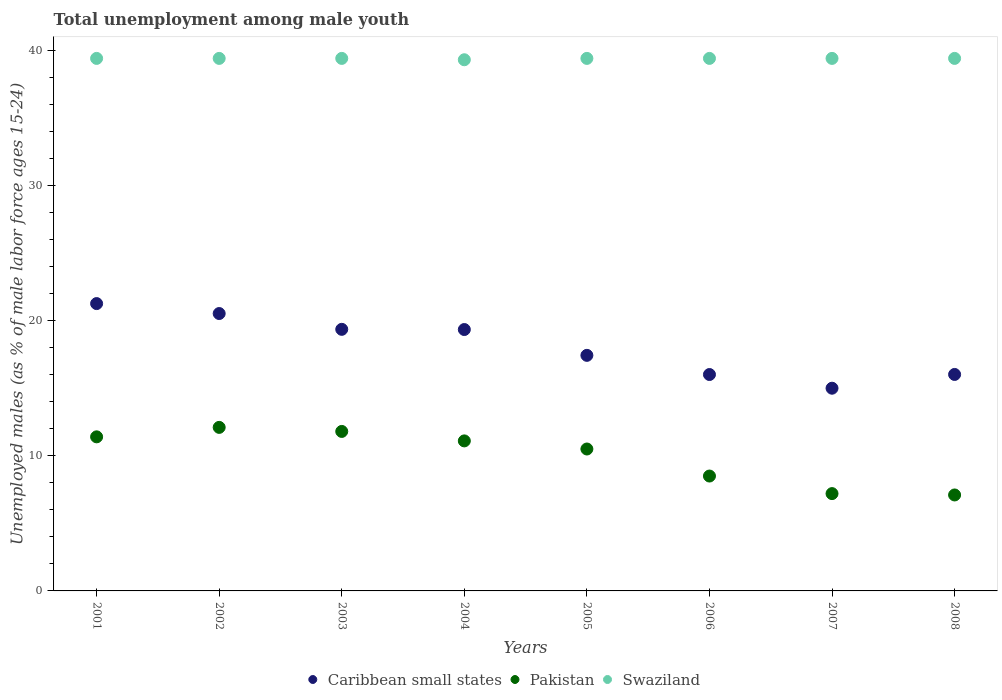Is the number of dotlines equal to the number of legend labels?
Your response must be concise. Yes. What is the percentage of unemployed males in in Pakistan in 2007?
Your answer should be very brief. 7.2. Across all years, what is the maximum percentage of unemployed males in in Swaziland?
Your answer should be compact. 39.4. Across all years, what is the minimum percentage of unemployed males in in Swaziland?
Your answer should be compact. 39.3. In which year was the percentage of unemployed males in in Swaziland minimum?
Your response must be concise. 2004. What is the total percentage of unemployed males in in Swaziland in the graph?
Keep it short and to the point. 315.1. What is the difference between the percentage of unemployed males in in Swaziland in 2004 and that in 2006?
Provide a succinct answer. -0.1. What is the difference between the percentage of unemployed males in in Pakistan in 2003 and the percentage of unemployed males in in Caribbean small states in 2001?
Offer a very short reply. -9.46. What is the average percentage of unemployed males in in Swaziland per year?
Your answer should be compact. 39.39. In the year 2002, what is the difference between the percentage of unemployed males in in Pakistan and percentage of unemployed males in in Swaziland?
Ensure brevity in your answer.  -27.3. In how many years, is the percentage of unemployed males in in Caribbean small states greater than 4 %?
Keep it short and to the point. 8. What is the ratio of the percentage of unemployed males in in Caribbean small states in 2002 to that in 2008?
Your answer should be very brief. 1.28. What is the difference between the highest and the second highest percentage of unemployed males in in Pakistan?
Provide a short and direct response. 0.3. What is the difference between the highest and the lowest percentage of unemployed males in in Pakistan?
Your answer should be very brief. 5. In how many years, is the percentage of unemployed males in in Pakistan greater than the average percentage of unemployed males in in Pakistan taken over all years?
Offer a very short reply. 5. Does the percentage of unemployed males in in Swaziland monotonically increase over the years?
Your response must be concise. No. Is the percentage of unemployed males in in Caribbean small states strictly greater than the percentage of unemployed males in in Swaziland over the years?
Your answer should be very brief. No. Is the percentage of unemployed males in in Pakistan strictly less than the percentage of unemployed males in in Caribbean small states over the years?
Give a very brief answer. Yes. How many dotlines are there?
Make the answer very short. 3. How many years are there in the graph?
Your response must be concise. 8. Does the graph contain any zero values?
Ensure brevity in your answer.  No. Does the graph contain grids?
Make the answer very short. No. How many legend labels are there?
Provide a succinct answer. 3. How are the legend labels stacked?
Offer a terse response. Horizontal. What is the title of the graph?
Ensure brevity in your answer.  Total unemployment among male youth. Does "Ireland" appear as one of the legend labels in the graph?
Offer a terse response. No. What is the label or title of the X-axis?
Offer a terse response. Years. What is the label or title of the Y-axis?
Keep it short and to the point. Unemployed males (as % of male labor force ages 15-24). What is the Unemployed males (as % of male labor force ages 15-24) in Caribbean small states in 2001?
Keep it short and to the point. 21.26. What is the Unemployed males (as % of male labor force ages 15-24) of Pakistan in 2001?
Your answer should be compact. 11.4. What is the Unemployed males (as % of male labor force ages 15-24) of Swaziland in 2001?
Provide a succinct answer. 39.4. What is the Unemployed males (as % of male labor force ages 15-24) in Caribbean small states in 2002?
Your answer should be very brief. 20.52. What is the Unemployed males (as % of male labor force ages 15-24) of Pakistan in 2002?
Provide a short and direct response. 12.1. What is the Unemployed males (as % of male labor force ages 15-24) in Swaziland in 2002?
Your answer should be compact. 39.4. What is the Unemployed males (as % of male labor force ages 15-24) of Caribbean small states in 2003?
Provide a short and direct response. 19.35. What is the Unemployed males (as % of male labor force ages 15-24) in Pakistan in 2003?
Make the answer very short. 11.8. What is the Unemployed males (as % of male labor force ages 15-24) in Swaziland in 2003?
Provide a succinct answer. 39.4. What is the Unemployed males (as % of male labor force ages 15-24) of Caribbean small states in 2004?
Your answer should be very brief. 19.34. What is the Unemployed males (as % of male labor force ages 15-24) in Pakistan in 2004?
Provide a short and direct response. 11.1. What is the Unemployed males (as % of male labor force ages 15-24) in Swaziland in 2004?
Your response must be concise. 39.3. What is the Unemployed males (as % of male labor force ages 15-24) of Caribbean small states in 2005?
Your response must be concise. 17.43. What is the Unemployed males (as % of male labor force ages 15-24) of Pakistan in 2005?
Keep it short and to the point. 10.5. What is the Unemployed males (as % of male labor force ages 15-24) in Swaziland in 2005?
Provide a short and direct response. 39.4. What is the Unemployed males (as % of male labor force ages 15-24) of Caribbean small states in 2006?
Your answer should be compact. 16.01. What is the Unemployed males (as % of male labor force ages 15-24) of Swaziland in 2006?
Your answer should be very brief. 39.4. What is the Unemployed males (as % of male labor force ages 15-24) in Caribbean small states in 2007?
Your response must be concise. 15. What is the Unemployed males (as % of male labor force ages 15-24) in Pakistan in 2007?
Keep it short and to the point. 7.2. What is the Unemployed males (as % of male labor force ages 15-24) in Swaziland in 2007?
Offer a terse response. 39.4. What is the Unemployed males (as % of male labor force ages 15-24) in Caribbean small states in 2008?
Offer a terse response. 16.02. What is the Unemployed males (as % of male labor force ages 15-24) of Pakistan in 2008?
Provide a succinct answer. 7.1. What is the Unemployed males (as % of male labor force ages 15-24) in Swaziland in 2008?
Provide a short and direct response. 39.4. Across all years, what is the maximum Unemployed males (as % of male labor force ages 15-24) of Caribbean small states?
Give a very brief answer. 21.26. Across all years, what is the maximum Unemployed males (as % of male labor force ages 15-24) in Pakistan?
Keep it short and to the point. 12.1. Across all years, what is the maximum Unemployed males (as % of male labor force ages 15-24) in Swaziland?
Your answer should be compact. 39.4. Across all years, what is the minimum Unemployed males (as % of male labor force ages 15-24) of Caribbean small states?
Make the answer very short. 15. Across all years, what is the minimum Unemployed males (as % of male labor force ages 15-24) in Pakistan?
Offer a very short reply. 7.1. Across all years, what is the minimum Unemployed males (as % of male labor force ages 15-24) of Swaziland?
Offer a very short reply. 39.3. What is the total Unemployed males (as % of male labor force ages 15-24) in Caribbean small states in the graph?
Your answer should be very brief. 144.93. What is the total Unemployed males (as % of male labor force ages 15-24) in Pakistan in the graph?
Provide a short and direct response. 79.7. What is the total Unemployed males (as % of male labor force ages 15-24) of Swaziland in the graph?
Give a very brief answer. 315.1. What is the difference between the Unemployed males (as % of male labor force ages 15-24) in Caribbean small states in 2001 and that in 2002?
Keep it short and to the point. 0.74. What is the difference between the Unemployed males (as % of male labor force ages 15-24) of Pakistan in 2001 and that in 2002?
Ensure brevity in your answer.  -0.7. What is the difference between the Unemployed males (as % of male labor force ages 15-24) of Caribbean small states in 2001 and that in 2003?
Your answer should be compact. 1.91. What is the difference between the Unemployed males (as % of male labor force ages 15-24) in Pakistan in 2001 and that in 2003?
Ensure brevity in your answer.  -0.4. What is the difference between the Unemployed males (as % of male labor force ages 15-24) in Caribbean small states in 2001 and that in 2004?
Provide a succinct answer. 1.92. What is the difference between the Unemployed males (as % of male labor force ages 15-24) in Caribbean small states in 2001 and that in 2005?
Your response must be concise. 3.83. What is the difference between the Unemployed males (as % of male labor force ages 15-24) in Caribbean small states in 2001 and that in 2006?
Provide a succinct answer. 5.25. What is the difference between the Unemployed males (as % of male labor force ages 15-24) in Swaziland in 2001 and that in 2006?
Provide a succinct answer. 0. What is the difference between the Unemployed males (as % of male labor force ages 15-24) of Caribbean small states in 2001 and that in 2007?
Offer a terse response. 6.26. What is the difference between the Unemployed males (as % of male labor force ages 15-24) in Caribbean small states in 2001 and that in 2008?
Offer a terse response. 5.24. What is the difference between the Unemployed males (as % of male labor force ages 15-24) of Caribbean small states in 2002 and that in 2003?
Provide a succinct answer. 1.17. What is the difference between the Unemployed males (as % of male labor force ages 15-24) of Caribbean small states in 2002 and that in 2004?
Your response must be concise. 1.18. What is the difference between the Unemployed males (as % of male labor force ages 15-24) of Pakistan in 2002 and that in 2004?
Your answer should be compact. 1. What is the difference between the Unemployed males (as % of male labor force ages 15-24) in Caribbean small states in 2002 and that in 2005?
Make the answer very short. 3.09. What is the difference between the Unemployed males (as % of male labor force ages 15-24) of Swaziland in 2002 and that in 2005?
Your answer should be compact. 0. What is the difference between the Unemployed males (as % of male labor force ages 15-24) in Caribbean small states in 2002 and that in 2006?
Give a very brief answer. 4.51. What is the difference between the Unemployed males (as % of male labor force ages 15-24) in Caribbean small states in 2002 and that in 2007?
Offer a very short reply. 5.53. What is the difference between the Unemployed males (as % of male labor force ages 15-24) in Caribbean small states in 2002 and that in 2008?
Your answer should be very brief. 4.51. What is the difference between the Unemployed males (as % of male labor force ages 15-24) of Caribbean small states in 2003 and that in 2004?
Your answer should be very brief. 0.01. What is the difference between the Unemployed males (as % of male labor force ages 15-24) in Pakistan in 2003 and that in 2004?
Offer a terse response. 0.7. What is the difference between the Unemployed males (as % of male labor force ages 15-24) in Swaziland in 2003 and that in 2004?
Your answer should be very brief. 0.1. What is the difference between the Unemployed males (as % of male labor force ages 15-24) of Caribbean small states in 2003 and that in 2005?
Provide a succinct answer. 1.92. What is the difference between the Unemployed males (as % of male labor force ages 15-24) in Pakistan in 2003 and that in 2005?
Your response must be concise. 1.3. What is the difference between the Unemployed males (as % of male labor force ages 15-24) in Swaziland in 2003 and that in 2005?
Offer a terse response. 0. What is the difference between the Unemployed males (as % of male labor force ages 15-24) of Caribbean small states in 2003 and that in 2006?
Your answer should be very brief. 3.34. What is the difference between the Unemployed males (as % of male labor force ages 15-24) in Caribbean small states in 2003 and that in 2007?
Offer a terse response. 4.36. What is the difference between the Unemployed males (as % of male labor force ages 15-24) in Caribbean small states in 2003 and that in 2008?
Your answer should be very brief. 3.34. What is the difference between the Unemployed males (as % of male labor force ages 15-24) in Pakistan in 2003 and that in 2008?
Your answer should be very brief. 4.7. What is the difference between the Unemployed males (as % of male labor force ages 15-24) of Swaziland in 2003 and that in 2008?
Ensure brevity in your answer.  0. What is the difference between the Unemployed males (as % of male labor force ages 15-24) of Caribbean small states in 2004 and that in 2005?
Your answer should be very brief. 1.91. What is the difference between the Unemployed males (as % of male labor force ages 15-24) in Pakistan in 2004 and that in 2005?
Provide a short and direct response. 0.6. What is the difference between the Unemployed males (as % of male labor force ages 15-24) of Swaziland in 2004 and that in 2005?
Offer a terse response. -0.1. What is the difference between the Unemployed males (as % of male labor force ages 15-24) in Caribbean small states in 2004 and that in 2006?
Provide a short and direct response. 3.33. What is the difference between the Unemployed males (as % of male labor force ages 15-24) in Caribbean small states in 2004 and that in 2007?
Your answer should be compact. 4.34. What is the difference between the Unemployed males (as % of male labor force ages 15-24) in Swaziland in 2004 and that in 2007?
Keep it short and to the point. -0.1. What is the difference between the Unemployed males (as % of male labor force ages 15-24) in Caribbean small states in 2004 and that in 2008?
Keep it short and to the point. 3.32. What is the difference between the Unemployed males (as % of male labor force ages 15-24) in Pakistan in 2004 and that in 2008?
Keep it short and to the point. 4. What is the difference between the Unemployed males (as % of male labor force ages 15-24) in Caribbean small states in 2005 and that in 2006?
Give a very brief answer. 1.42. What is the difference between the Unemployed males (as % of male labor force ages 15-24) in Caribbean small states in 2005 and that in 2007?
Your answer should be very brief. 2.43. What is the difference between the Unemployed males (as % of male labor force ages 15-24) in Pakistan in 2005 and that in 2007?
Make the answer very short. 3.3. What is the difference between the Unemployed males (as % of male labor force ages 15-24) in Swaziland in 2005 and that in 2007?
Keep it short and to the point. 0. What is the difference between the Unemployed males (as % of male labor force ages 15-24) in Caribbean small states in 2005 and that in 2008?
Your answer should be very brief. 1.41. What is the difference between the Unemployed males (as % of male labor force ages 15-24) of Pakistan in 2005 and that in 2008?
Your response must be concise. 3.4. What is the difference between the Unemployed males (as % of male labor force ages 15-24) of Caribbean small states in 2006 and that in 2007?
Ensure brevity in your answer.  1.01. What is the difference between the Unemployed males (as % of male labor force ages 15-24) in Pakistan in 2006 and that in 2007?
Your response must be concise. 1.3. What is the difference between the Unemployed males (as % of male labor force ages 15-24) in Caribbean small states in 2006 and that in 2008?
Provide a short and direct response. -0.01. What is the difference between the Unemployed males (as % of male labor force ages 15-24) of Caribbean small states in 2007 and that in 2008?
Provide a short and direct response. -1.02. What is the difference between the Unemployed males (as % of male labor force ages 15-24) in Swaziland in 2007 and that in 2008?
Make the answer very short. 0. What is the difference between the Unemployed males (as % of male labor force ages 15-24) of Caribbean small states in 2001 and the Unemployed males (as % of male labor force ages 15-24) of Pakistan in 2002?
Your answer should be compact. 9.16. What is the difference between the Unemployed males (as % of male labor force ages 15-24) in Caribbean small states in 2001 and the Unemployed males (as % of male labor force ages 15-24) in Swaziland in 2002?
Your answer should be compact. -18.14. What is the difference between the Unemployed males (as % of male labor force ages 15-24) of Pakistan in 2001 and the Unemployed males (as % of male labor force ages 15-24) of Swaziland in 2002?
Your response must be concise. -28. What is the difference between the Unemployed males (as % of male labor force ages 15-24) in Caribbean small states in 2001 and the Unemployed males (as % of male labor force ages 15-24) in Pakistan in 2003?
Your answer should be compact. 9.46. What is the difference between the Unemployed males (as % of male labor force ages 15-24) in Caribbean small states in 2001 and the Unemployed males (as % of male labor force ages 15-24) in Swaziland in 2003?
Your answer should be compact. -18.14. What is the difference between the Unemployed males (as % of male labor force ages 15-24) of Caribbean small states in 2001 and the Unemployed males (as % of male labor force ages 15-24) of Pakistan in 2004?
Offer a terse response. 10.16. What is the difference between the Unemployed males (as % of male labor force ages 15-24) of Caribbean small states in 2001 and the Unemployed males (as % of male labor force ages 15-24) of Swaziland in 2004?
Your answer should be very brief. -18.04. What is the difference between the Unemployed males (as % of male labor force ages 15-24) in Pakistan in 2001 and the Unemployed males (as % of male labor force ages 15-24) in Swaziland in 2004?
Ensure brevity in your answer.  -27.9. What is the difference between the Unemployed males (as % of male labor force ages 15-24) of Caribbean small states in 2001 and the Unemployed males (as % of male labor force ages 15-24) of Pakistan in 2005?
Provide a short and direct response. 10.76. What is the difference between the Unemployed males (as % of male labor force ages 15-24) of Caribbean small states in 2001 and the Unemployed males (as % of male labor force ages 15-24) of Swaziland in 2005?
Keep it short and to the point. -18.14. What is the difference between the Unemployed males (as % of male labor force ages 15-24) in Pakistan in 2001 and the Unemployed males (as % of male labor force ages 15-24) in Swaziland in 2005?
Provide a short and direct response. -28. What is the difference between the Unemployed males (as % of male labor force ages 15-24) in Caribbean small states in 2001 and the Unemployed males (as % of male labor force ages 15-24) in Pakistan in 2006?
Ensure brevity in your answer.  12.76. What is the difference between the Unemployed males (as % of male labor force ages 15-24) of Caribbean small states in 2001 and the Unemployed males (as % of male labor force ages 15-24) of Swaziland in 2006?
Ensure brevity in your answer.  -18.14. What is the difference between the Unemployed males (as % of male labor force ages 15-24) of Pakistan in 2001 and the Unemployed males (as % of male labor force ages 15-24) of Swaziland in 2006?
Make the answer very short. -28. What is the difference between the Unemployed males (as % of male labor force ages 15-24) in Caribbean small states in 2001 and the Unemployed males (as % of male labor force ages 15-24) in Pakistan in 2007?
Your answer should be very brief. 14.06. What is the difference between the Unemployed males (as % of male labor force ages 15-24) of Caribbean small states in 2001 and the Unemployed males (as % of male labor force ages 15-24) of Swaziland in 2007?
Your answer should be compact. -18.14. What is the difference between the Unemployed males (as % of male labor force ages 15-24) in Pakistan in 2001 and the Unemployed males (as % of male labor force ages 15-24) in Swaziland in 2007?
Offer a very short reply. -28. What is the difference between the Unemployed males (as % of male labor force ages 15-24) in Caribbean small states in 2001 and the Unemployed males (as % of male labor force ages 15-24) in Pakistan in 2008?
Offer a terse response. 14.16. What is the difference between the Unemployed males (as % of male labor force ages 15-24) in Caribbean small states in 2001 and the Unemployed males (as % of male labor force ages 15-24) in Swaziland in 2008?
Give a very brief answer. -18.14. What is the difference between the Unemployed males (as % of male labor force ages 15-24) of Pakistan in 2001 and the Unemployed males (as % of male labor force ages 15-24) of Swaziland in 2008?
Ensure brevity in your answer.  -28. What is the difference between the Unemployed males (as % of male labor force ages 15-24) of Caribbean small states in 2002 and the Unemployed males (as % of male labor force ages 15-24) of Pakistan in 2003?
Offer a terse response. 8.72. What is the difference between the Unemployed males (as % of male labor force ages 15-24) in Caribbean small states in 2002 and the Unemployed males (as % of male labor force ages 15-24) in Swaziland in 2003?
Your answer should be very brief. -18.88. What is the difference between the Unemployed males (as % of male labor force ages 15-24) of Pakistan in 2002 and the Unemployed males (as % of male labor force ages 15-24) of Swaziland in 2003?
Make the answer very short. -27.3. What is the difference between the Unemployed males (as % of male labor force ages 15-24) in Caribbean small states in 2002 and the Unemployed males (as % of male labor force ages 15-24) in Pakistan in 2004?
Give a very brief answer. 9.42. What is the difference between the Unemployed males (as % of male labor force ages 15-24) in Caribbean small states in 2002 and the Unemployed males (as % of male labor force ages 15-24) in Swaziland in 2004?
Provide a succinct answer. -18.78. What is the difference between the Unemployed males (as % of male labor force ages 15-24) of Pakistan in 2002 and the Unemployed males (as % of male labor force ages 15-24) of Swaziland in 2004?
Provide a short and direct response. -27.2. What is the difference between the Unemployed males (as % of male labor force ages 15-24) in Caribbean small states in 2002 and the Unemployed males (as % of male labor force ages 15-24) in Pakistan in 2005?
Your answer should be very brief. 10.02. What is the difference between the Unemployed males (as % of male labor force ages 15-24) of Caribbean small states in 2002 and the Unemployed males (as % of male labor force ages 15-24) of Swaziland in 2005?
Keep it short and to the point. -18.88. What is the difference between the Unemployed males (as % of male labor force ages 15-24) of Pakistan in 2002 and the Unemployed males (as % of male labor force ages 15-24) of Swaziland in 2005?
Provide a short and direct response. -27.3. What is the difference between the Unemployed males (as % of male labor force ages 15-24) in Caribbean small states in 2002 and the Unemployed males (as % of male labor force ages 15-24) in Pakistan in 2006?
Offer a terse response. 12.02. What is the difference between the Unemployed males (as % of male labor force ages 15-24) in Caribbean small states in 2002 and the Unemployed males (as % of male labor force ages 15-24) in Swaziland in 2006?
Your response must be concise. -18.88. What is the difference between the Unemployed males (as % of male labor force ages 15-24) in Pakistan in 2002 and the Unemployed males (as % of male labor force ages 15-24) in Swaziland in 2006?
Your answer should be compact. -27.3. What is the difference between the Unemployed males (as % of male labor force ages 15-24) in Caribbean small states in 2002 and the Unemployed males (as % of male labor force ages 15-24) in Pakistan in 2007?
Your answer should be compact. 13.32. What is the difference between the Unemployed males (as % of male labor force ages 15-24) of Caribbean small states in 2002 and the Unemployed males (as % of male labor force ages 15-24) of Swaziland in 2007?
Keep it short and to the point. -18.88. What is the difference between the Unemployed males (as % of male labor force ages 15-24) of Pakistan in 2002 and the Unemployed males (as % of male labor force ages 15-24) of Swaziland in 2007?
Your answer should be compact. -27.3. What is the difference between the Unemployed males (as % of male labor force ages 15-24) in Caribbean small states in 2002 and the Unemployed males (as % of male labor force ages 15-24) in Pakistan in 2008?
Ensure brevity in your answer.  13.42. What is the difference between the Unemployed males (as % of male labor force ages 15-24) of Caribbean small states in 2002 and the Unemployed males (as % of male labor force ages 15-24) of Swaziland in 2008?
Your response must be concise. -18.88. What is the difference between the Unemployed males (as % of male labor force ages 15-24) of Pakistan in 2002 and the Unemployed males (as % of male labor force ages 15-24) of Swaziland in 2008?
Ensure brevity in your answer.  -27.3. What is the difference between the Unemployed males (as % of male labor force ages 15-24) in Caribbean small states in 2003 and the Unemployed males (as % of male labor force ages 15-24) in Pakistan in 2004?
Make the answer very short. 8.25. What is the difference between the Unemployed males (as % of male labor force ages 15-24) in Caribbean small states in 2003 and the Unemployed males (as % of male labor force ages 15-24) in Swaziland in 2004?
Make the answer very short. -19.95. What is the difference between the Unemployed males (as % of male labor force ages 15-24) of Pakistan in 2003 and the Unemployed males (as % of male labor force ages 15-24) of Swaziland in 2004?
Ensure brevity in your answer.  -27.5. What is the difference between the Unemployed males (as % of male labor force ages 15-24) of Caribbean small states in 2003 and the Unemployed males (as % of male labor force ages 15-24) of Pakistan in 2005?
Keep it short and to the point. 8.85. What is the difference between the Unemployed males (as % of male labor force ages 15-24) in Caribbean small states in 2003 and the Unemployed males (as % of male labor force ages 15-24) in Swaziland in 2005?
Your response must be concise. -20.05. What is the difference between the Unemployed males (as % of male labor force ages 15-24) of Pakistan in 2003 and the Unemployed males (as % of male labor force ages 15-24) of Swaziland in 2005?
Keep it short and to the point. -27.6. What is the difference between the Unemployed males (as % of male labor force ages 15-24) in Caribbean small states in 2003 and the Unemployed males (as % of male labor force ages 15-24) in Pakistan in 2006?
Keep it short and to the point. 10.85. What is the difference between the Unemployed males (as % of male labor force ages 15-24) in Caribbean small states in 2003 and the Unemployed males (as % of male labor force ages 15-24) in Swaziland in 2006?
Your answer should be very brief. -20.05. What is the difference between the Unemployed males (as % of male labor force ages 15-24) in Pakistan in 2003 and the Unemployed males (as % of male labor force ages 15-24) in Swaziland in 2006?
Provide a succinct answer. -27.6. What is the difference between the Unemployed males (as % of male labor force ages 15-24) in Caribbean small states in 2003 and the Unemployed males (as % of male labor force ages 15-24) in Pakistan in 2007?
Give a very brief answer. 12.15. What is the difference between the Unemployed males (as % of male labor force ages 15-24) in Caribbean small states in 2003 and the Unemployed males (as % of male labor force ages 15-24) in Swaziland in 2007?
Provide a succinct answer. -20.05. What is the difference between the Unemployed males (as % of male labor force ages 15-24) of Pakistan in 2003 and the Unemployed males (as % of male labor force ages 15-24) of Swaziland in 2007?
Provide a short and direct response. -27.6. What is the difference between the Unemployed males (as % of male labor force ages 15-24) in Caribbean small states in 2003 and the Unemployed males (as % of male labor force ages 15-24) in Pakistan in 2008?
Make the answer very short. 12.25. What is the difference between the Unemployed males (as % of male labor force ages 15-24) of Caribbean small states in 2003 and the Unemployed males (as % of male labor force ages 15-24) of Swaziland in 2008?
Provide a short and direct response. -20.05. What is the difference between the Unemployed males (as % of male labor force ages 15-24) in Pakistan in 2003 and the Unemployed males (as % of male labor force ages 15-24) in Swaziland in 2008?
Make the answer very short. -27.6. What is the difference between the Unemployed males (as % of male labor force ages 15-24) in Caribbean small states in 2004 and the Unemployed males (as % of male labor force ages 15-24) in Pakistan in 2005?
Keep it short and to the point. 8.84. What is the difference between the Unemployed males (as % of male labor force ages 15-24) in Caribbean small states in 2004 and the Unemployed males (as % of male labor force ages 15-24) in Swaziland in 2005?
Ensure brevity in your answer.  -20.06. What is the difference between the Unemployed males (as % of male labor force ages 15-24) of Pakistan in 2004 and the Unemployed males (as % of male labor force ages 15-24) of Swaziland in 2005?
Provide a succinct answer. -28.3. What is the difference between the Unemployed males (as % of male labor force ages 15-24) in Caribbean small states in 2004 and the Unemployed males (as % of male labor force ages 15-24) in Pakistan in 2006?
Offer a terse response. 10.84. What is the difference between the Unemployed males (as % of male labor force ages 15-24) in Caribbean small states in 2004 and the Unemployed males (as % of male labor force ages 15-24) in Swaziland in 2006?
Give a very brief answer. -20.06. What is the difference between the Unemployed males (as % of male labor force ages 15-24) in Pakistan in 2004 and the Unemployed males (as % of male labor force ages 15-24) in Swaziland in 2006?
Offer a very short reply. -28.3. What is the difference between the Unemployed males (as % of male labor force ages 15-24) of Caribbean small states in 2004 and the Unemployed males (as % of male labor force ages 15-24) of Pakistan in 2007?
Keep it short and to the point. 12.14. What is the difference between the Unemployed males (as % of male labor force ages 15-24) in Caribbean small states in 2004 and the Unemployed males (as % of male labor force ages 15-24) in Swaziland in 2007?
Make the answer very short. -20.06. What is the difference between the Unemployed males (as % of male labor force ages 15-24) of Pakistan in 2004 and the Unemployed males (as % of male labor force ages 15-24) of Swaziland in 2007?
Keep it short and to the point. -28.3. What is the difference between the Unemployed males (as % of male labor force ages 15-24) in Caribbean small states in 2004 and the Unemployed males (as % of male labor force ages 15-24) in Pakistan in 2008?
Ensure brevity in your answer.  12.24. What is the difference between the Unemployed males (as % of male labor force ages 15-24) in Caribbean small states in 2004 and the Unemployed males (as % of male labor force ages 15-24) in Swaziland in 2008?
Offer a very short reply. -20.06. What is the difference between the Unemployed males (as % of male labor force ages 15-24) in Pakistan in 2004 and the Unemployed males (as % of male labor force ages 15-24) in Swaziland in 2008?
Provide a short and direct response. -28.3. What is the difference between the Unemployed males (as % of male labor force ages 15-24) of Caribbean small states in 2005 and the Unemployed males (as % of male labor force ages 15-24) of Pakistan in 2006?
Keep it short and to the point. 8.93. What is the difference between the Unemployed males (as % of male labor force ages 15-24) in Caribbean small states in 2005 and the Unemployed males (as % of male labor force ages 15-24) in Swaziland in 2006?
Keep it short and to the point. -21.97. What is the difference between the Unemployed males (as % of male labor force ages 15-24) in Pakistan in 2005 and the Unemployed males (as % of male labor force ages 15-24) in Swaziland in 2006?
Provide a succinct answer. -28.9. What is the difference between the Unemployed males (as % of male labor force ages 15-24) in Caribbean small states in 2005 and the Unemployed males (as % of male labor force ages 15-24) in Pakistan in 2007?
Your answer should be compact. 10.23. What is the difference between the Unemployed males (as % of male labor force ages 15-24) in Caribbean small states in 2005 and the Unemployed males (as % of male labor force ages 15-24) in Swaziland in 2007?
Ensure brevity in your answer.  -21.97. What is the difference between the Unemployed males (as % of male labor force ages 15-24) in Pakistan in 2005 and the Unemployed males (as % of male labor force ages 15-24) in Swaziland in 2007?
Keep it short and to the point. -28.9. What is the difference between the Unemployed males (as % of male labor force ages 15-24) of Caribbean small states in 2005 and the Unemployed males (as % of male labor force ages 15-24) of Pakistan in 2008?
Give a very brief answer. 10.33. What is the difference between the Unemployed males (as % of male labor force ages 15-24) of Caribbean small states in 2005 and the Unemployed males (as % of male labor force ages 15-24) of Swaziland in 2008?
Keep it short and to the point. -21.97. What is the difference between the Unemployed males (as % of male labor force ages 15-24) of Pakistan in 2005 and the Unemployed males (as % of male labor force ages 15-24) of Swaziland in 2008?
Your answer should be very brief. -28.9. What is the difference between the Unemployed males (as % of male labor force ages 15-24) in Caribbean small states in 2006 and the Unemployed males (as % of male labor force ages 15-24) in Pakistan in 2007?
Provide a short and direct response. 8.81. What is the difference between the Unemployed males (as % of male labor force ages 15-24) of Caribbean small states in 2006 and the Unemployed males (as % of male labor force ages 15-24) of Swaziland in 2007?
Make the answer very short. -23.39. What is the difference between the Unemployed males (as % of male labor force ages 15-24) in Pakistan in 2006 and the Unemployed males (as % of male labor force ages 15-24) in Swaziland in 2007?
Provide a short and direct response. -30.9. What is the difference between the Unemployed males (as % of male labor force ages 15-24) of Caribbean small states in 2006 and the Unemployed males (as % of male labor force ages 15-24) of Pakistan in 2008?
Provide a short and direct response. 8.91. What is the difference between the Unemployed males (as % of male labor force ages 15-24) of Caribbean small states in 2006 and the Unemployed males (as % of male labor force ages 15-24) of Swaziland in 2008?
Offer a very short reply. -23.39. What is the difference between the Unemployed males (as % of male labor force ages 15-24) in Pakistan in 2006 and the Unemployed males (as % of male labor force ages 15-24) in Swaziland in 2008?
Your answer should be compact. -30.9. What is the difference between the Unemployed males (as % of male labor force ages 15-24) of Caribbean small states in 2007 and the Unemployed males (as % of male labor force ages 15-24) of Pakistan in 2008?
Give a very brief answer. 7.9. What is the difference between the Unemployed males (as % of male labor force ages 15-24) in Caribbean small states in 2007 and the Unemployed males (as % of male labor force ages 15-24) in Swaziland in 2008?
Your response must be concise. -24.4. What is the difference between the Unemployed males (as % of male labor force ages 15-24) of Pakistan in 2007 and the Unemployed males (as % of male labor force ages 15-24) of Swaziland in 2008?
Make the answer very short. -32.2. What is the average Unemployed males (as % of male labor force ages 15-24) in Caribbean small states per year?
Provide a succinct answer. 18.12. What is the average Unemployed males (as % of male labor force ages 15-24) of Pakistan per year?
Provide a short and direct response. 9.96. What is the average Unemployed males (as % of male labor force ages 15-24) in Swaziland per year?
Provide a succinct answer. 39.39. In the year 2001, what is the difference between the Unemployed males (as % of male labor force ages 15-24) in Caribbean small states and Unemployed males (as % of male labor force ages 15-24) in Pakistan?
Provide a succinct answer. 9.86. In the year 2001, what is the difference between the Unemployed males (as % of male labor force ages 15-24) in Caribbean small states and Unemployed males (as % of male labor force ages 15-24) in Swaziland?
Provide a succinct answer. -18.14. In the year 2001, what is the difference between the Unemployed males (as % of male labor force ages 15-24) in Pakistan and Unemployed males (as % of male labor force ages 15-24) in Swaziland?
Keep it short and to the point. -28. In the year 2002, what is the difference between the Unemployed males (as % of male labor force ages 15-24) of Caribbean small states and Unemployed males (as % of male labor force ages 15-24) of Pakistan?
Offer a very short reply. 8.42. In the year 2002, what is the difference between the Unemployed males (as % of male labor force ages 15-24) of Caribbean small states and Unemployed males (as % of male labor force ages 15-24) of Swaziland?
Ensure brevity in your answer.  -18.88. In the year 2002, what is the difference between the Unemployed males (as % of male labor force ages 15-24) of Pakistan and Unemployed males (as % of male labor force ages 15-24) of Swaziland?
Give a very brief answer. -27.3. In the year 2003, what is the difference between the Unemployed males (as % of male labor force ages 15-24) of Caribbean small states and Unemployed males (as % of male labor force ages 15-24) of Pakistan?
Give a very brief answer. 7.55. In the year 2003, what is the difference between the Unemployed males (as % of male labor force ages 15-24) of Caribbean small states and Unemployed males (as % of male labor force ages 15-24) of Swaziland?
Ensure brevity in your answer.  -20.05. In the year 2003, what is the difference between the Unemployed males (as % of male labor force ages 15-24) of Pakistan and Unemployed males (as % of male labor force ages 15-24) of Swaziland?
Provide a succinct answer. -27.6. In the year 2004, what is the difference between the Unemployed males (as % of male labor force ages 15-24) of Caribbean small states and Unemployed males (as % of male labor force ages 15-24) of Pakistan?
Offer a very short reply. 8.24. In the year 2004, what is the difference between the Unemployed males (as % of male labor force ages 15-24) of Caribbean small states and Unemployed males (as % of male labor force ages 15-24) of Swaziland?
Keep it short and to the point. -19.96. In the year 2004, what is the difference between the Unemployed males (as % of male labor force ages 15-24) in Pakistan and Unemployed males (as % of male labor force ages 15-24) in Swaziland?
Provide a short and direct response. -28.2. In the year 2005, what is the difference between the Unemployed males (as % of male labor force ages 15-24) in Caribbean small states and Unemployed males (as % of male labor force ages 15-24) in Pakistan?
Offer a very short reply. 6.93. In the year 2005, what is the difference between the Unemployed males (as % of male labor force ages 15-24) in Caribbean small states and Unemployed males (as % of male labor force ages 15-24) in Swaziland?
Ensure brevity in your answer.  -21.97. In the year 2005, what is the difference between the Unemployed males (as % of male labor force ages 15-24) of Pakistan and Unemployed males (as % of male labor force ages 15-24) of Swaziland?
Make the answer very short. -28.9. In the year 2006, what is the difference between the Unemployed males (as % of male labor force ages 15-24) in Caribbean small states and Unemployed males (as % of male labor force ages 15-24) in Pakistan?
Ensure brevity in your answer.  7.51. In the year 2006, what is the difference between the Unemployed males (as % of male labor force ages 15-24) of Caribbean small states and Unemployed males (as % of male labor force ages 15-24) of Swaziland?
Provide a short and direct response. -23.39. In the year 2006, what is the difference between the Unemployed males (as % of male labor force ages 15-24) in Pakistan and Unemployed males (as % of male labor force ages 15-24) in Swaziland?
Your response must be concise. -30.9. In the year 2007, what is the difference between the Unemployed males (as % of male labor force ages 15-24) in Caribbean small states and Unemployed males (as % of male labor force ages 15-24) in Pakistan?
Your answer should be compact. 7.8. In the year 2007, what is the difference between the Unemployed males (as % of male labor force ages 15-24) in Caribbean small states and Unemployed males (as % of male labor force ages 15-24) in Swaziland?
Your response must be concise. -24.4. In the year 2007, what is the difference between the Unemployed males (as % of male labor force ages 15-24) in Pakistan and Unemployed males (as % of male labor force ages 15-24) in Swaziland?
Offer a very short reply. -32.2. In the year 2008, what is the difference between the Unemployed males (as % of male labor force ages 15-24) of Caribbean small states and Unemployed males (as % of male labor force ages 15-24) of Pakistan?
Ensure brevity in your answer.  8.92. In the year 2008, what is the difference between the Unemployed males (as % of male labor force ages 15-24) of Caribbean small states and Unemployed males (as % of male labor force ages 15-24) of Swaziland?
Ensure brevity in your answer.  -23.38. In the year 2008, what is the difference between the Unemployed males (as % of male labor force ages 15-24) in Pakistan and Unemployed males (as % of male labor force ages 15-24) in Swaziland?
Offer a very short reply. -32.3. What is the ratio of the Unemployed males (as % of male labor force ages 15-24) of Caribbean small states in 2001 to that in 2002?
Your answer should be compact. 1.04. What is the ratio of the Unemployed males (as % of male labor force ages 15-24) in Pakistan in 2001 to that in 2002?
Ensure brevity in your answer.  0.94. What is the ratio of the Unemployed males (as % of male labor force ages 15-24) of Caribbean small states in 2001 to that in 2003?
Your answer should be compact. 1.1. What is the ratio of the Unemployed males (as % of male labor force ages 15-24) of Pakistan in 2001 to that in 2003?
Make the answer very short. 0.97. What is the ratio of the Unemployed males (as % of male labor force ages 15-24) in Caribbean small states in 2001 to that in 2004?
Give a very brief answer. 1.1. What is the ratio of the Unemployed males (as % of male labor force ages 15-24) in Pakistan in 2001 to that in 2004?
Offer a terse response. 1.03. What is the ratio of the Unemployed males (as % of male labor force ages 15-24) in Swaziland in 2001 to that in 2004?
Offer a terse response. 1. What is the ratio of the Unemployed males (as % of male labor force ages 15-24) of Caribbean small states in 2001 to that in 2005?
Give a very brief answer. 1.22. What is the ratio of the Unemployed males (as % of male labor force ages 15-24) in Pakistan in 2001 to that in 2005?
Make the answer very short. 1.09. What is the ratio of the Unemployed males (as % of male labor force ages 15-24) in Swaziland in 2001 to that in 2005?
Make the answer very short. 1. What is the ratio of the Unemployed males (as % of male labor force ages 15-24) in Caribbean small states in 2001 to that in 2006?
Give a very brief answer. 1.33. What is the ratio of the Unemployed males (as % of male labor force ages 15-24) in Pakistan in 2001 to that in 2006?
Your response must be concise. 1.34. What is the ratio of the Unemployed males (as % of male labor force ages 15-24) in Swaziland in 2001 to that in 2006?
Offer a terse response. 1. What is the ratio of the Unemployed males (as % of male labor force ages 15-24) in Caribbean small states in 2001 to that in 2007?
Keep it short and to the point. 1.42. What is the ratio of the Unemployed males (as % of male labor force ages 15-24) of Pakistan in 2001 to that in 2007?
Ensure brevity in your answer.  1.58. What is the ratio of the Unemployed males (as % of male labor force ages 15-24) of Swaziland in 2001 to that in 2007?
Ensure brevity in your answer.  1. What is the ratio of the Unemployed males (as % of male labor force ages 15-24) of Caribbean small states in 2001 to that in 2008?
Provide a short and direct response. 1.33. What is the ratio of the Unemployed males (as % of male labor force ages 15-24) in Pakistan in 2001 to that in 2008?
Your answer should be very brief. 1.61. What is the ratio of the Unemployed males (as % of male labor force ages 15-24) in Caribbean small states in 2002 to that in 2003?
Offer a terse response. 1.06. What is the ratio of the Unemployed males (as % of male labor force ages 15-24) of Pakistan in 2002 to that in 2003?
Provide a succinct answer. 1.03. What is the ratio of the Unemployed males (as % of male labor force ages 15-24) of Caribbean small states in 2002 to that in 2004?
Keep it short and to the point. 1.06. What is the ratio of the Unemployed males (as % of male labor force ages 15-24) in Pakistan in 2002 to that in 2004?
Give a very brief answer. 1.09. What is the ratio of the Unemployed males (as % of male labor force ages 15-24) of Swaziland in 2002 to that in 2004?
Your answer should be compact. 1. What is the ratio of the Unemployed males (as % of male labor force ages 15-24) in Caribbean small states in 2002 to that in 2005?
Offer a terse response. 1.18. What is the ratio of the Unemployed males (as % of male labor force ages 15-24) of Pakistan in 2002 to that in 2005?
Keep it short and to the point. 1.15. What is the ratio of the Unemployed males (as % of male labor force ages 15-24) in Swaziland in 2002 to that in 2005?
Give a very brief answer. 1. What is the ratio of the Unemployed males (as % of male labor force ages 15-24) in Caribbean small states in 2002 to that in 2006?
Offer a terse response. 1.28. What is the ratio of the Unemployed males (as % of male labor force ages 15-24) of Pakistan in 2002 to that in 2006?
Give a very brief answer. 1.42. What is the ratio of the Unemployed males (as % of male labor force ages 15-24) in Swaziland in 2002 to that in 2006?
Offer a very short reply. 1. What is the ratio of the Unemployed males (as % of male labor force ages 15-24) in Caribbean small states in 2002 to that in 2007?
Your answer should be very brief. 1.37. What is the ratio of the Unemployed males (as % of male labor force ages 15-24) of Pakistan in 2002 to that in 2007?
Provide a succinct answer. 1.68. What is the ratio of the Unemployed males (as % of male labor force ages 15-24) of Swaziland in 2002 to that in 2007?
Offer a very short reply. 1. What is the ratio of the Unemployed males (as % of male labor force ages 15-24) in Caribbean small states in 2002 to that in 2008?
Give a very brief answer. 1.28. What is the ratio of the Unemployed males (as % of male labor force ages 15-24) of Pakistan in 2002 to that in 2008?
Provide a succinct answer. 1.7. What is the ratio of the Unemployed males (as % of male labor force ages 15-24) in Pakistan in 2003 to that in 2004?
Ensure brevity in your answer.  1.06. What is the ratio of the Unemployed males (as % of male labor force ages 15-24) in Swaziland in 2003 to that in 2004?
Offer a very short reply. 1. What is the ratio of the Unemployed males (as % of male labor force ages 15-24) in Caribbean small states in 2003 to that in 2005?
Your answer should be very brief. 1.11. What is the ratio of the Unemployed males (as % of male labor force ages 15-24) in Pakistan in 2003 to that in 2005?
Your answer should be very brief. 1.12. What is the ratio of the Unemployed males (as % of male labor force ages 15-24) of Swaziland in 2003 to that in 2005?
Give a very brief answer. 1. What is the ratio of the Unemployed males (as % of male labor force ages 15-24) of Caribbean small states in 2003 to that in 2006?
Your answer should be very brief. 1.21. What is the ratio of the Unemployed males (as % of male labor force ages 15-24) in Pakistan in 2003 to that in 2006?
Ensure brevity in your answer.  1.39. What is the ratio of the Unemployed males (as % of male labor force ages 15-24) in Caribbean small states in 2003 to that in 2007?
Give a very brief answer. 1.29. What is the ratio of the Unemployed males (as % of male labor force ages 15-24) in Pakistan in 2003 to that in 2007?
Your response must be concise. 1.64. What is the ratio of the Unemployed males (as % of male labor force ages 15-24) in Swaziland in 2003 to that in 2007?
Provide a short and direct response. 1. What is the ratio of the Unemployed males (as % of male labor force ages 15-24) of Caribbean small states in 2003 to that in 2008?
Make the answer very short. 1.21. What is the ratio of the Unemployed males (as % of male labor force ages 15-24) of Pakistan in 2003 to that in 2008?
Your response must be concise. 1.66. What is the ratio of the Unemployed males (as % of male labor force ages 15-24) of Caribbean small states in 2004 to that in 2005?
Provide a succinct answer. 1.11. What is the ratio of the Unemployed males (as % of male labor force ages 15-24) of Pakistan in 2004 to that in 2005?
Provide a short and direct response. 1.06. What is the ratio of the Unemployed males (as % of male labor force ages 15-24) in Caribbean small states in 2004 to that in 2006?
Provide a succinct answer. 1.21. What is the ratio of the Unemployed males (as % of male labor force ages 15-24) of Pakistan in 2004 to that in 2006?
Offer a terse response. 1.31. What is the ratio of the Unemployed males (as % of male labor force ages 15-24) in Swaziland in 2004 to that in 2006?
Give a very brief answer. 1. What is the ratio of the Unemployed males (as % of male labor force ages 15-24) in Caribbean small states in 2004 to that in 2007?
Make the answer very short. 1.29. What is the ratio of the Unemployed males (as % of male labor force ages 15-24) of Pakistan in 2004 to that in 2007?
Your answer should be compact. 1.54. What is the ratio of the Unemployed males (as % of male labor force ages 15-24) of Swaziland in 2004 to that in 2007?
Provide a succinct answer. 1. What is the ratio of the Unemployed males (as % of male labor force ages 15-24) in Caribbean small states in 2004 to that in 2008?
Give a very brief answer. 1.21. What is the ratio of the Unemployed males (as % of male labor force ages 15-24) in Pakistan in 2004 to that in 2008?
Provide a short and direct response. 1.56. What is the ratio of the Unemployed males (as % of male labor force ages 15-24) in Swaziland in 2004 to that in 2008?
Your answer should be very brief. 1. What is the ratio of the Unemployed males (as % of male labor force ages 15-24) of Caribbean small states in 2005 to that in 2006?
Make the answer very short. 1.09. What is the ratio of the Unemployed males (as % of male labor force ages 15-24) of Pakistan in 2005 to that in 2006?
Keep it short and to the point. 1.24. What is the ratio of the Unemployed males (as % of male labor force ages 15-24) in Caribbean small states in 2005 to that in 2007?
Keep it short and to the point. 1.16. What is the ratio of the Unemployed males (as % of male labor force ages 15-24) of Pakistan in 2005 to that in 2007?
Ensure brevity in your answer.  1.46. What is the ratio of the Unemployed males (as % of male labor force ages 15-24) in Caribbean small states in 2005 to that in 2008?
Offer a terse response. 1.09. What is the ratio of the Unemployed males (as % of male labor force ages 15-24) of Pakistan in 2005 to that in 2008?
Give a very brief answer. 1.48. What is the ratio of the Unemployed males (as % of male labor force ages 15-24) of Caribbean small states in 2006 to that in 2007?
Offer a very short reply. 1.07. What is the ratio of the Unemployed males (as % of male labor force ages 15-24) of Pakistan in 2006 to that in 2007?
Offer a very short reply. 1.18. What is the ratio of the Unemployed males (as % of male labor force ages 15-24) in Swaziland in 2006 to that in 2007?
Keep it short and to the point. 1. What is the ratio of the Unemployed males (as % of male labor force ages 15-24) in Pakistan in 2006 to that in 2008?
Ensure brevity in your answer.  1.2. What is the ratio of the Unemployed males (as % of male labor force ages 15-24) of Caribbean small states in 2007 to that in 2008?
Offer a terse response. 0.94. What is the ratio of the Unemployed males (as % of male labor force ages 15-24) of Pakistan in 2007 to that in 2008?
Keep it short and to the point. 1.01. What is the difference between the highest and the second highest Unemployed males (as % of male labor force ages 15-24) in Caribbean small states?
Offer a terse response. 0.74. What is the difference between the highest and the second highest Unemployed males (as % of male labor force ages 15-24) of Pakistan?
Your answer should be compact. 0.3. What is the difference between the highest and the second highest Unemployed males (as % of male labor force ages 15-24) in Swaziland?
Offer a very short reply. 0. What is the difference between the highest and the lowest Unemployed males (as % of male labor force ages 15-24) in Caribbean small states?
Ensure brevity in your answer.  6.26. What is the difference between the highest and the lowest Unemployed males (as % of male labor force ages 15-24) of Swaziland?
Provide a succinct answer. 0.1. 